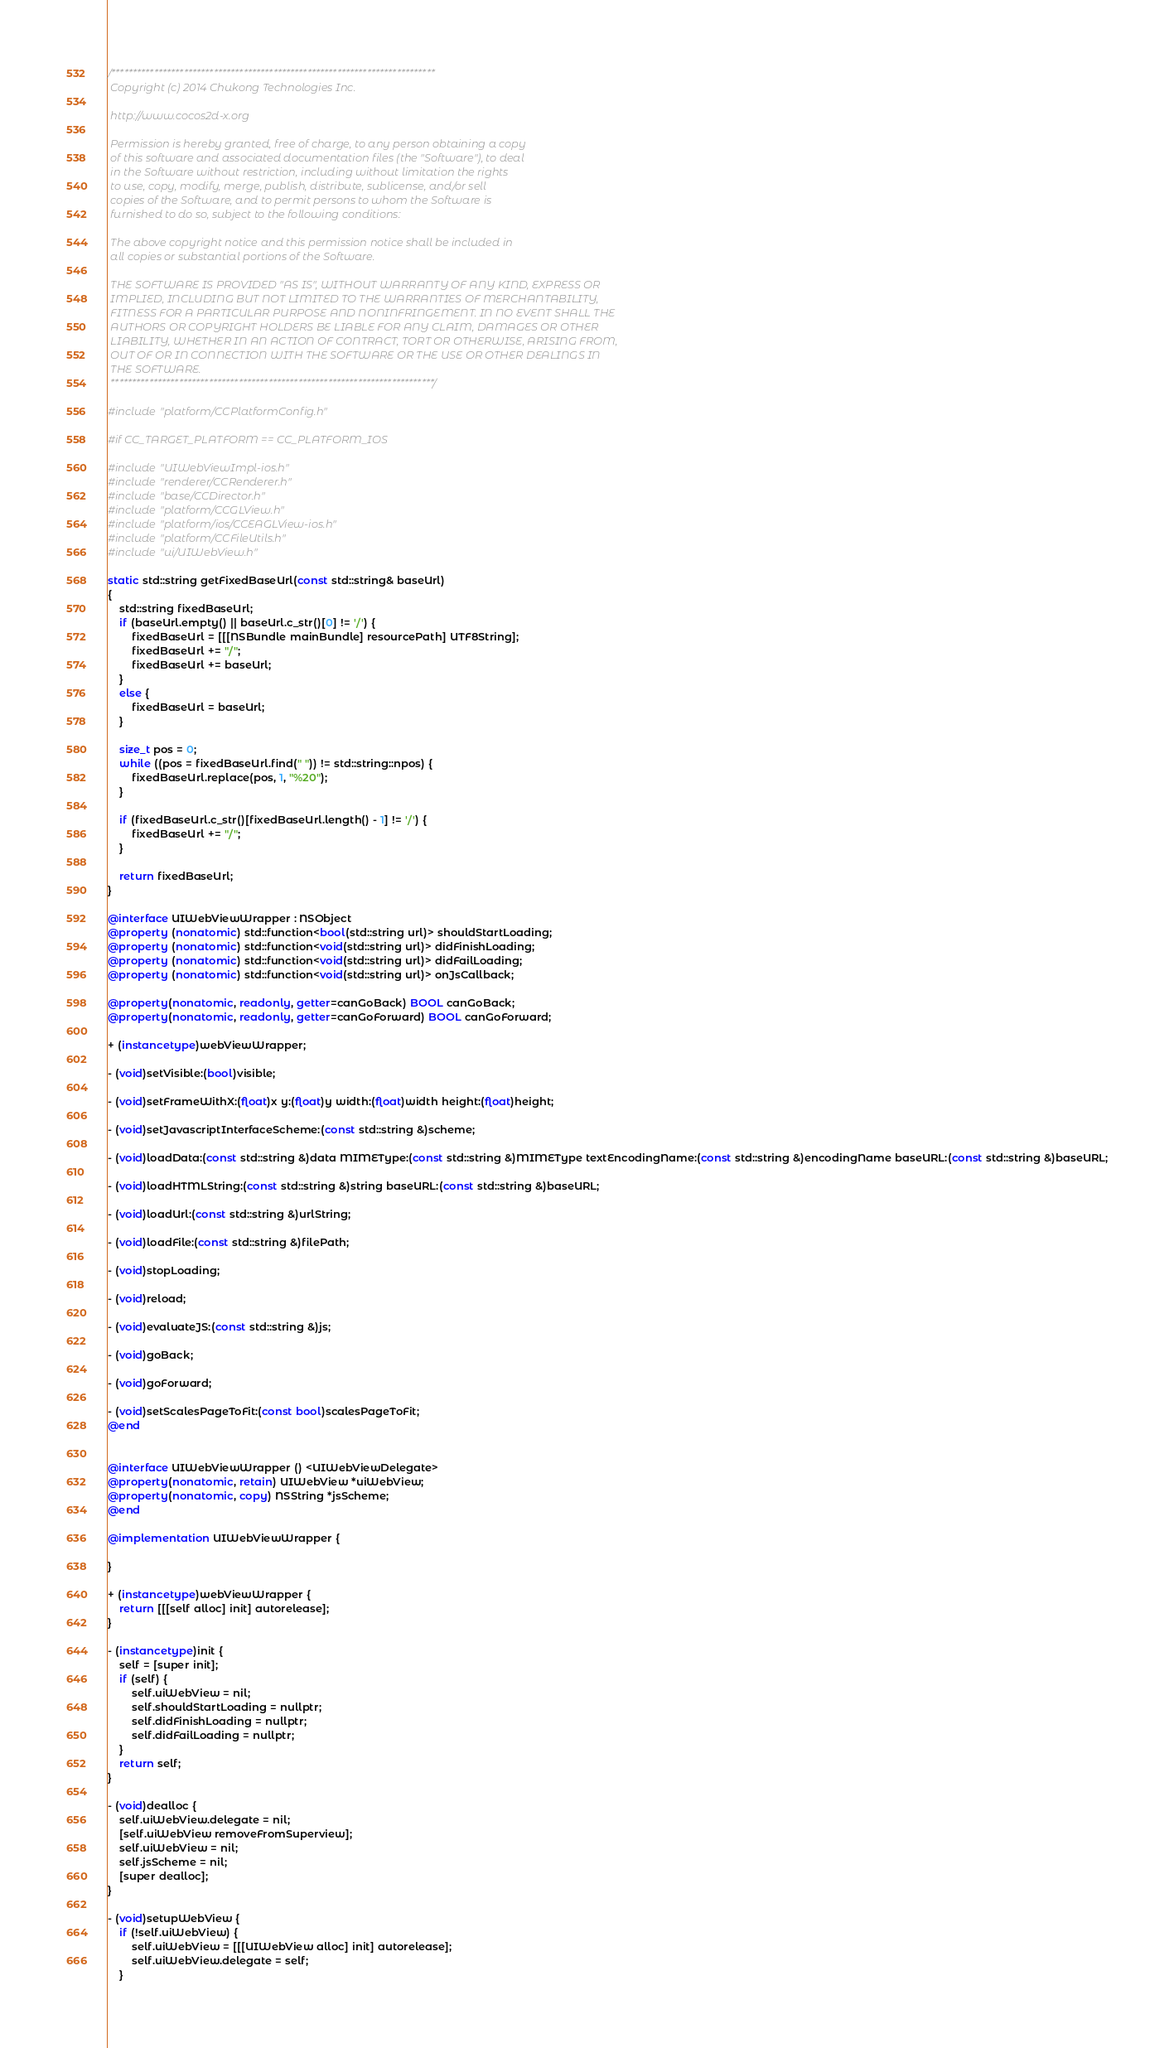<code> <loc_0><loc_0><loc_500><loc_500><_ObjectiveC_>/****************************************************************************
 Copyright (c) 2014 Chukong Technologies Inc.
 
 http://www.cocos2d-x.org
 
 Permission is hereby granted, free of charge, to any person obtaining a copy
 of this software and associated documentation files (the "Software"), to deal
 in the Software without restriction, including without limitation the rights
 to use, copy, modify, merge, publish, distribute, sublicense, and/or sell
 copies of the Software, and to permit persons to whom the Software is
 furnished to do so, subject to the following conditions:
 
 The above copyright notice and this permission notice shall be included in
 all copies or substantial portions of the Software.
 
 THE SOFTWARE IS PROVIDED "AS IS", WITHOUT WARRANTY OF ANY KIND, EXPRESS OR
 IMPLIED, INCLUDING BUT NOT LIMITED TO THE WARRANTIES OF MERCHANTABILITY,
 FITNESS FOR A PARTICULAR PURPOSE AND NONINFRINGEMENT. IN NO EVENT SHALL THE
 AUTHORS OR COPYRIGHT HOLDERS BE LIABLE FOR ANY CLAIM, DAMAGES OR OTHER
 LIABILITY, WHETHER IN AN ACTION OF CONTRACT, TORT OR OTHERWISE, ARISING FROM,
 OUT OF OR IN CONNECTION WITH THE SOFTWARE OR THE USE OR OTHER DEALINGS IN
 THE SOFTWARE.
 ****************************************************************************/

#include "platform/CCPlatformConfig.h"

#if CC_TARGET_PLATFORM == CC_PLATFORM_IOS

#include "UIWebViewImpl-ios.h"
#include "renderer/CCRenderer.h"
#include "base/CCDirector.h"
#include "platform/CCGLView.h"
#include "platform/ios/CCEAGLView-ios.h"
#include "platform/CCFileUtils.h"
#include "ui/UIWebView.h"

static std::string getFixedBaseUrl(const std::string& baseUrl)
{
    std::string fixedBaseUrl;
    if (baseUrl.empty() || baseUrl.c_str()[0] != '/') {
        fixedBaseUrl = [[[NSBundle mainBundle] resourcePath] UTF8String];
        fixedBaseUrl += "/";
        fixedBaseUrl += baseUrl;
    }
    else {
        fixedBaseUrl = baseUrl;
    }
    
    size_t pos = 0;
    while ((pos = fixedBaseUrl.find(" ")) != std::string::npos) {
        fixedBaseUrl.replace(pos, 1, "%20");
    }
    
    if (fixedBaseUrl.c_str()[fixedBaseUrl.length() - 1] != '/') {
        fixedBaseUrl += "/";
    }
    
    return fixedBaseUrl;
}

@interface UIWebViewWrapper : NSObject
@property (nonatomic) std::function<bool(std::string url)> shouldStartLoading;
@property (nonatomic) std::function<void(std::string url)> didFinishLoading;
@property (nonatomic) std::function<void(std::string url)> didFailLoading;
@property (nonatomic) std::function<void(std::string url)> onJsCallback;

@property(nonatomic, readonly, getter=canGoBack) BOOL canGoBack;
@property(nonatomic, readonly, getter=canGoForward) BOOL canGoForward;

+ (instancetype)webViewWrapper;

- (void)setVisible:(bool)visible;

- (void)setFrameWithX:(float)x y:(float)y width:(float)width height:(float)height;

- (void)setJavascriptInterfaceScheme:(const std::string &)scheme;

- (void)loadData:(const std::string &)data MIMEType:(const std::string &)MIMEType textEncodingName:(const std::string &)encodingName baseURL:(const std::string &)baseURL;

- (void)loadHTMLString:(const std::string &)string baseURL:(const std::string &)baseURL;

- (void)loadUrl:(const std::string &)urlString;

- (void)loadFile:(const std::string &)filePath;

- (void)stopLoading;

- (void)reload;

- (void)evaluateJS:(const std::string &)js;

- (void)goBack;

- (void)goForward;

- (void)setScalesPageToFit:(const bool)scalesPageToFit;
@end


@interface UIWebViewWrapper () <UIWebViewDelegate>
@property(nonatomic, retain) UIWebView *uiWebView;
@property(nonatomic, copy) NSString *jsScheme;
@end

@implementation UIWebViewWrapper {
    
}

+ (instancetype)webViewWrapper {
    return [[[self alloc] init] autorelease];
}

- (instancetype)init {
    self = [super init];
    if (self) {
        self.uiWebView = nil;
        self.shouldStartLoading = nullptr;
        self.didFinishLoading = nullptr;
        self.didFailLoading = nullptr;
    }
    return self;
}

- (void)dealloc {
    self.uiWebView.delegate = nil;
    [self.uiWebView removeFromSuperview];
    self.uiWebView = nil;
    self.jsScheme = nil;
    [super dealloc];
}

- (void)setupWebView {
    if (!self.uiWebView) {
        self.uiWebView = [[[UIWebView alloc] init] autorelease];
        self.uiWebView.delegate = self;
    }</code> 